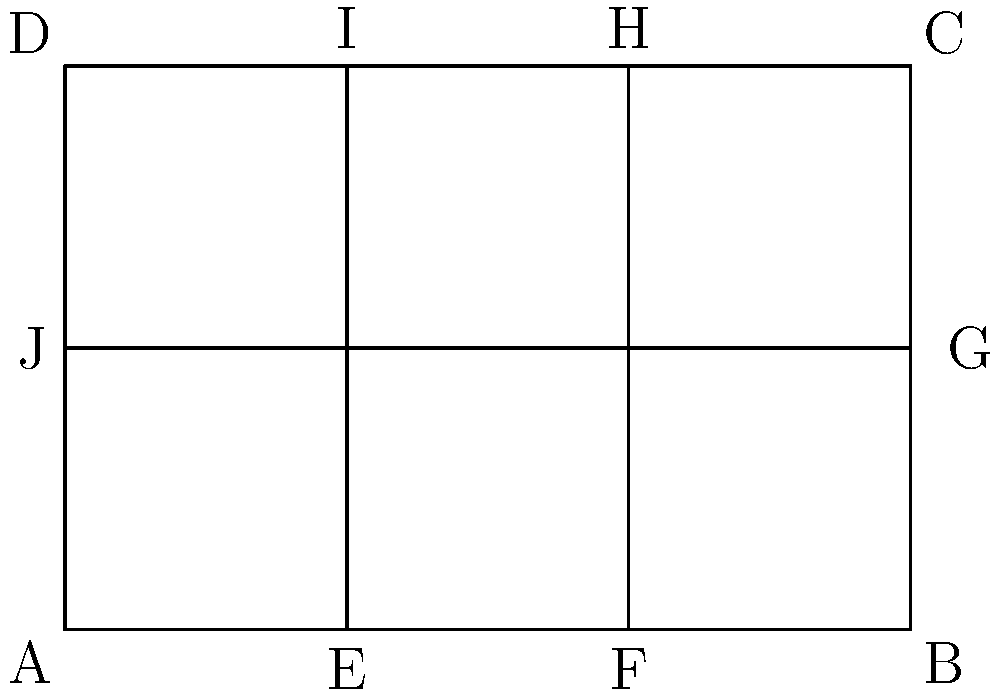In a rectangular neighborhood ABCD, three streets divide the area as shown in the diagram. If a police patrol needs to cover all streets in the neighborhood, including the perimeter, what is the minimum distance the patrol car must travel to cover all streets exactly once and return to the starting point? Assume the neighborhood has dimensions of 6 units by 4 units. To solve this problem, we'll use the concept of Eulerian circuits and the Chinese Postman Problem. Here's a step-by-step approach:

1. Identify the vertices (intersections) and edges (street segments) in the graph:
   - Vertices: A, B, C, D, E, F, G, H, I, J
   - Edges: AB, BC, CD, DA, EI, FH, JG, AE, EF, FB, DI, IH, HC, AG, GC, DJ

2. Calculate the total length of all edges:
   - Perimeter: $2(6 + 4) = 20$ units
   - Interior streets: $4 + 4 + \sqrt{4^2 + 6^2} = 8 + \sqrt{52}$ units
   - Total length: $20 + 8 + \sqrt{52} = 28 + \sqrt{52}$ units

3. Check if all vertices have an even degree (number of connected edges):
   - A, B, C, D have degree 3 (odd)
   - E, F, G, H, I, J have degree 2 (even)

4. Since there are vertices with odd degrees, we need to add the shortest possible connections to make all degrees even:
   - Connect A to C: $\sqrt{6^2 + 4^2} = \sqrt{52}$ units
   - Connect B to D: $4$ units

5. Calculate the total distance:
   - Original street length: $28 + \sqrt{52}$ units
   - Added connections: $\sqrt{52} + 4$ units
   - Total: $28 + \sqrt{52} + \sqrt{52} + 4 = 32 + 2\sqrt{52}$ units

Therefore, the minimum distance the patrol car must travel to cover all streets exactly once and return to the starting point is $32 + 2\sqrt{52}$ units.
Answer: $32 + 2\sqrt{52}$ units 